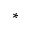<formula> <loc_0><loc_0><loc_500><loc_500>*</formula> 